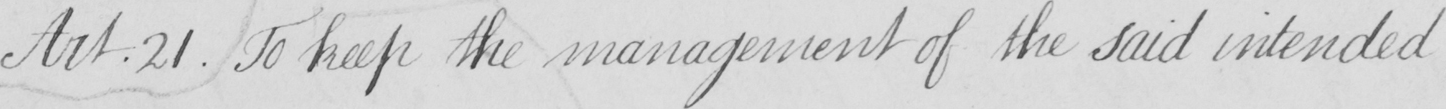What is written in this line of handwriting? Art . 21 . To keep the management of the said intended 